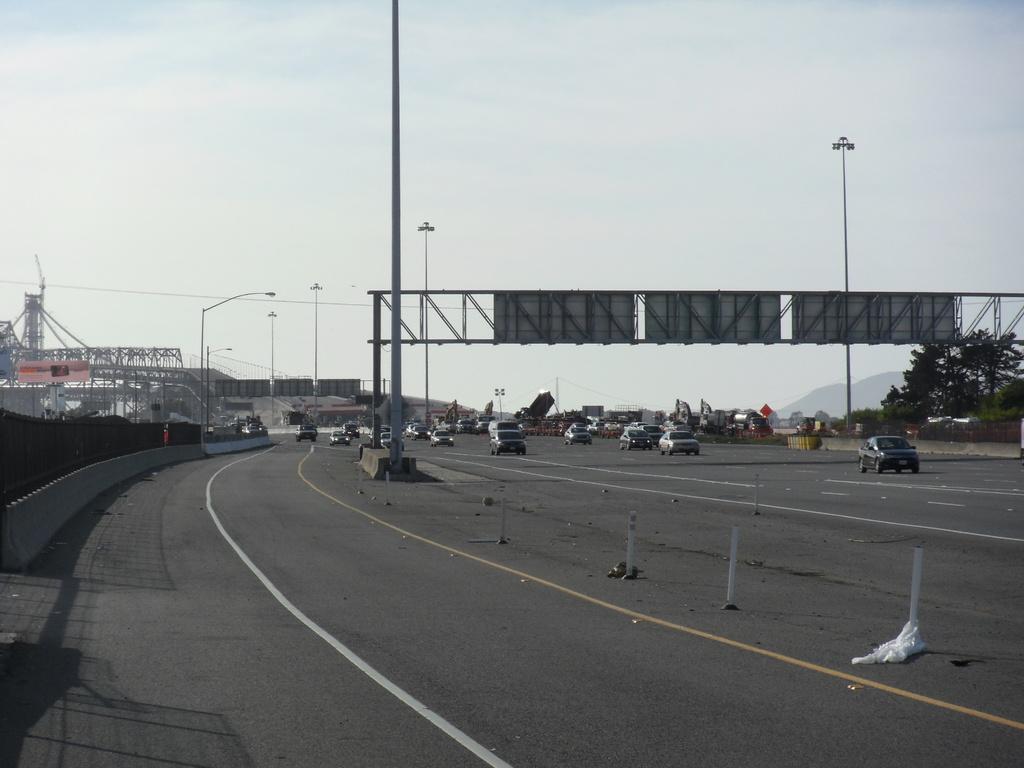Please provide a concise description of this image. In the foreground I can see a fence, boards, street lights and fleets of cars on the road. In the background I can see a bridge, tower, trees and mountains. At the top I can see the sky. This image is taken during a day on the road. 